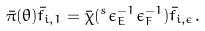Convert formula to latex. <formula><loc_0><loc_0><loc_500><loc_500>\bar { \pi } ( \theta ) \bar { f } _ { i , 1 } = \bar { \chi } ( ^ { s } \epsilon _ { E } ^ { - 1 } \epsilon _ { F } ^ { - 1 } ) \bar { f } _ { i , \epsilon } .</formula> 